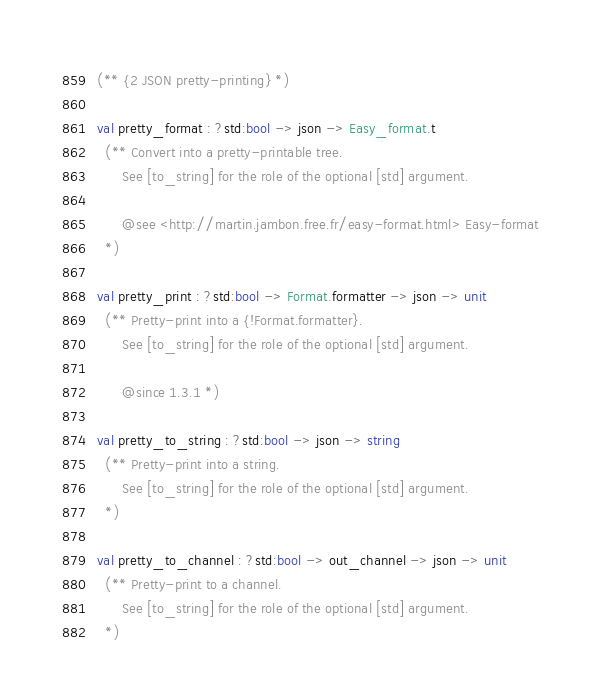Convert code to text. <code><loc_0><loc_0><loc_500><loc_500><_OCaml_>(** {2 JSON pretty-printing} *)

val pretty_format : ?std:bool -> json -> Easy_format.t
  (** Convert into a pretty-printable tree.
      See [to_string] for the role of the optional [std] argument.

      @see <http://martin.jambon.free.fr/easy-format.html> Easy-format
  *)

val pretty_print : ?std:bool -> Format.formatter -> json -> unit
  (** Pretty-print into a {!Format.formatter}.
      See [to_string] for the role of the optional [std] argument.

      @since 1.3.1 *)

val pretty_to_string : ?std:bool -> json -> string
  (** Pretty-print into a string.
      See [to_string] for the role of the optional [std] argument.
  *)

val pretty_to_channel : ?std:bool -> out_channel -> json -> unit
  (** Pretty-print to a channel.
      See [to_string] for the role of the optional [std] argument.
  *)
</code> 